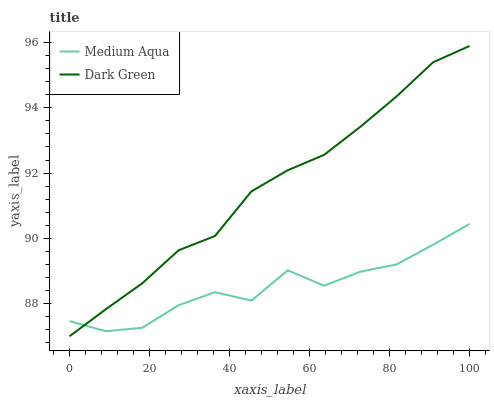Does Medium Aqua have the minimum area under the curve?
Answer yes or no. Yes. Does Dark Green have the maximum area under the curve?
Answer yes or no. Yes. Does Dark Green have the minimum area under the curve?
Answer yes or no. No. Is Dark Green the smoothest?
Answer yes or no. Yes. Is Medium Aqua the roughest?
Answer yes or no. Yes. Is Dark Green the roughest?
Answer yes or no. No. Does Dark Green have the lowest value?
Answer yes or no. Yes. Does Dark Green have the highest value?
Answer yes or no. Yes. Does Dark Green intersect Medium Aqua?
Answer yes or no. Yes. Is Dark Green less than Medium Aqua?
Answer yes or no. No. Is Dark Green greater than Medium Aqua?
Answer yes or no. No. 